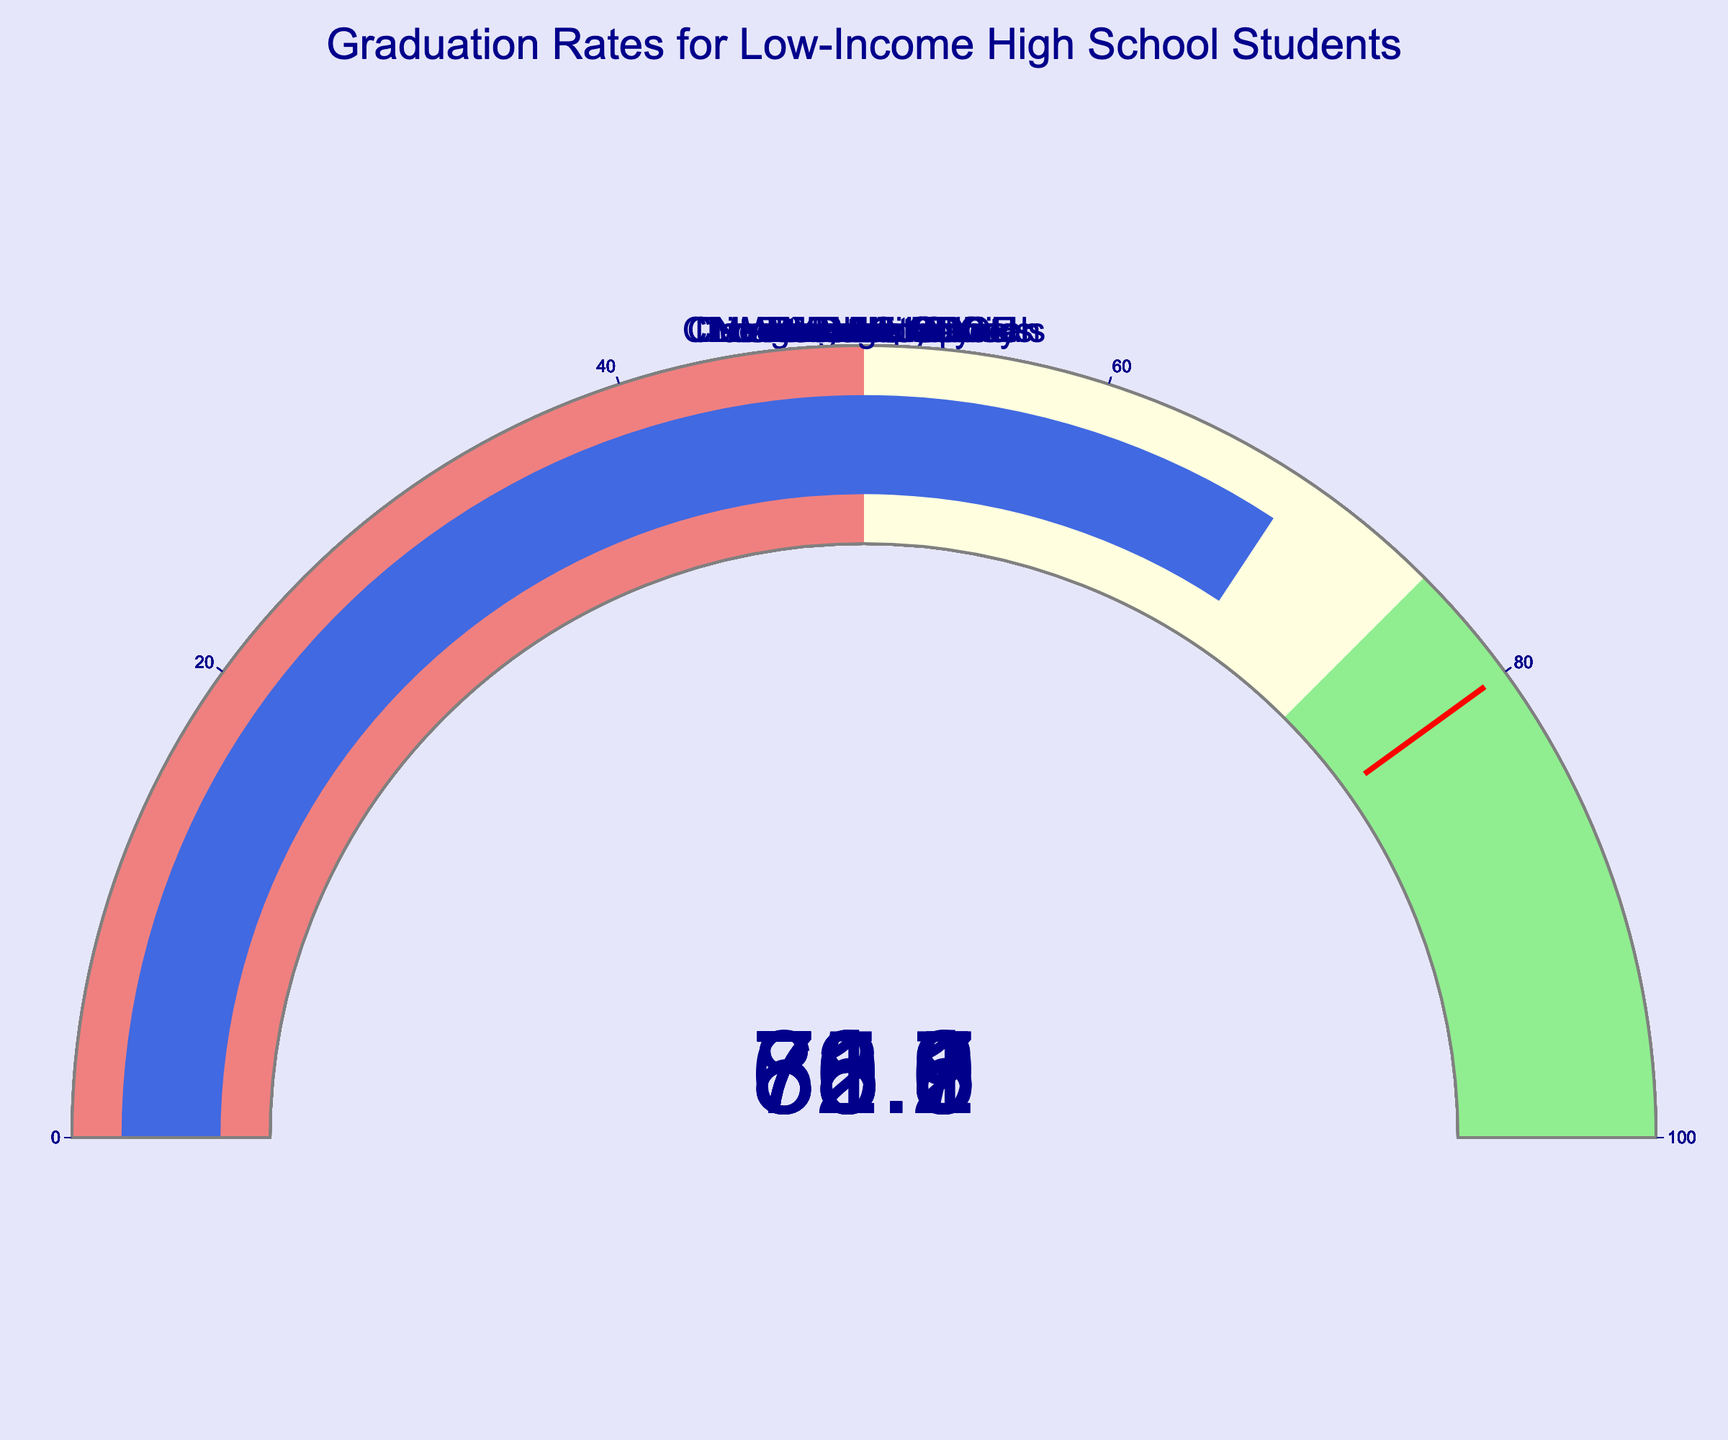What's the graduation rate for Baltimore City? The graduation rate for Baltimore City is directly shown on its gauge.
Answer: 70.5 Which school district has the highest graduation rate? By comparing all the graduation rates displayed on each gauge, Miami-Dade County has the highest rate.
Answer: Miami-Dade County How much higher is New York City DOE's graduation rate compared to that of Detroit Public Schools? New York City DOE's graduation rate is 78.9. Detroit Public Schools' graduation rate is 71.2. The difference is calculated as 78.9 - 71.2.
Answer: 7.7 What's the average graduation rate for the school districts shown in the chart? Sum all the graduation rates: (72.3 + 78.9 + 80.5 + 85.1 + 81.7 + 73.8 + 71.2 + 70.5 + 78.2 + 68.6) = 760.8. Divide by the number of districts (10).
Answer: 76.08 What color indicates graduation rates between 50 and 75? The color in the gauge chart that indicates graduation rates between 50 and 75 is light yellow.
Answer: Light yellow What's the range given on the gauges for graduation rates? Each gauge has a range indicated from 0 to 100.
Answer: 0 to 100 Which school districts have graduation rates below the threshold value of 80? Gauges indicate that the school districts with graduation rates below 80 are Los Angeles Unified, New York City DOE, Philadelphia, Detroit Public Schools, Baltimore City, Cleveland Metropolitan, and Washington DC.
Answer: Los Angeles Unified, New York City DOE, Philadelphia, Detroit Public Schools, Baltimore City, Cleveland Metropolitan, Washington DC What is the difference between the highest and the lowest graduation rates? The highest graduation rate is 85.1 (Miami-Dade County), and the lowest is 68.6 (Washington DC). The difference is calculated as 85.1 - 68.6.
Answer: 16.5 Which school district has a graduation rate closest to 75? By comparing the graduation rates, Philadelphia, with a graduation rate of 73.8, is closest to 75.
Answer: Philadelphia Are there more school districts below or above the threshold value of 80? There are 7 school districts with graduation rates below 80 and 3 above 80.
Answer: More below 